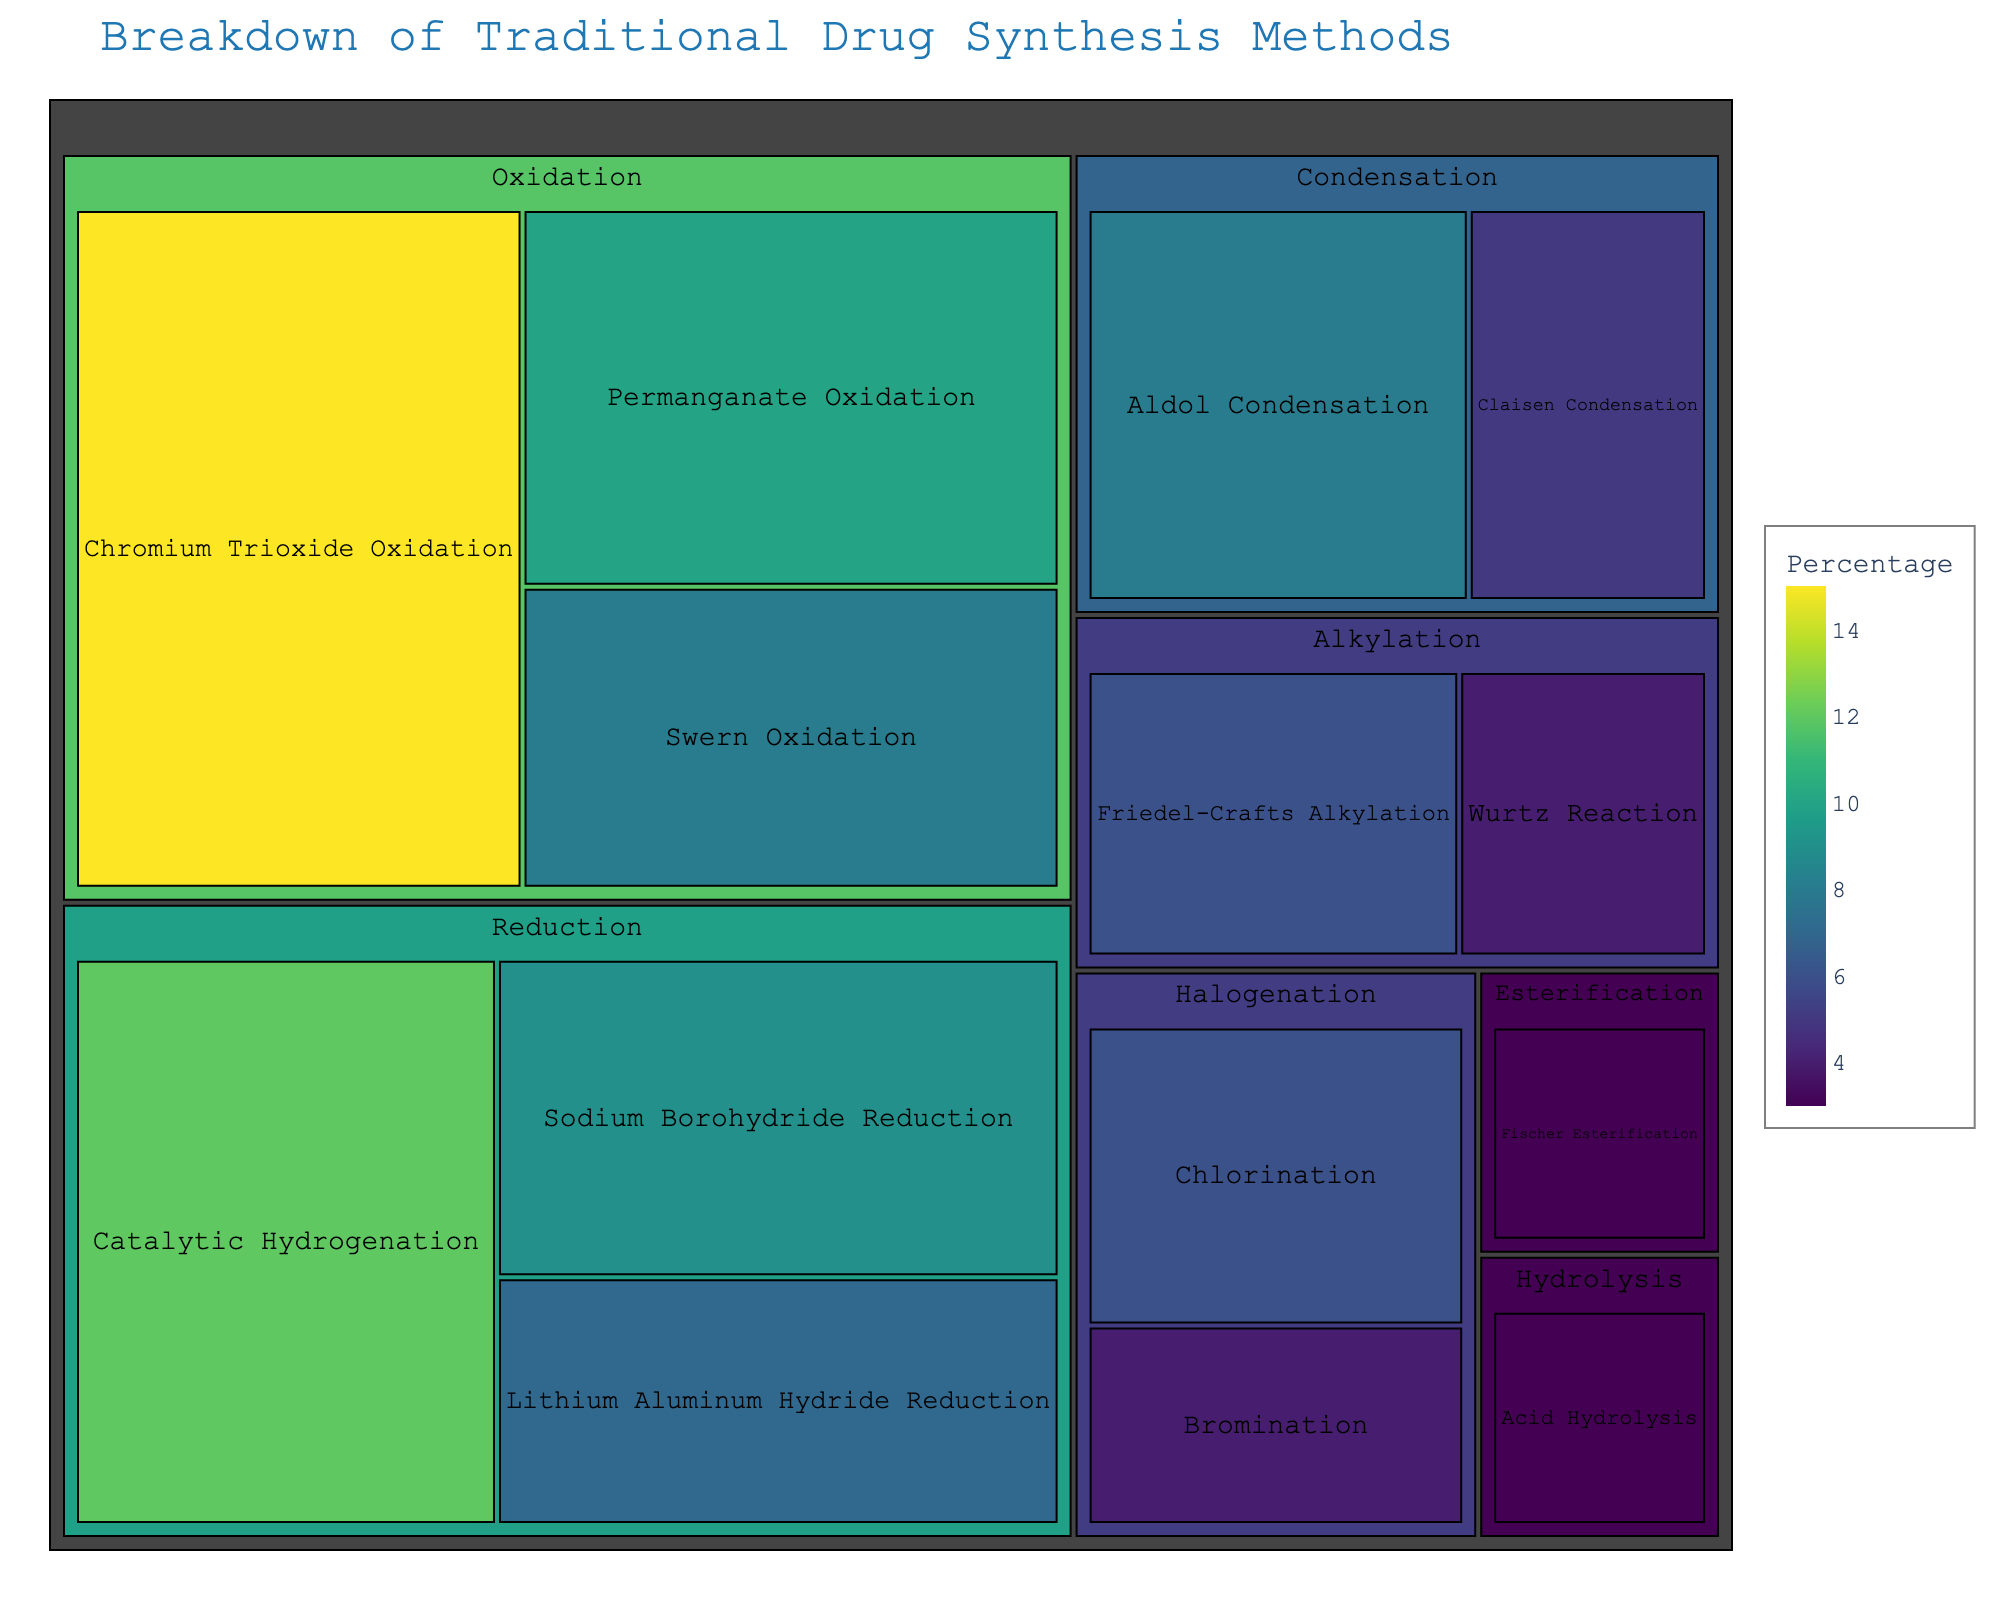What is the title of the treemap? The title is typically located at the top of the figure and provides a brief description of what the figure is about. In this case, the title is "Breakdown of Traditional Drug Synthesis Methods".
Answer: Breakdown of Traditional Drug Synthesis Methods Which method has the highest percentage among all chemical reaction types? The largest block in the treemap indicates the method with the highest percentage. From the data, it's "Chromium Trioxide Oxidation" in the "Oxidation" category with 15%.
Answer: Chromium Trioxide Oxidation What is the total percentage of all reduction methods combined? To find the total percentage for reduction methods, sum the percentages of all methods under the "Reduction" category: Catalytic Hydrogenation (12%), Sodium Borohydride Reduction (9%), Lithium Aluminum Hydride Reduction (7%). So, 12 + 9 + 7 = 28%.
Answer: 28% Which category has the most diverse types of methods, and how many methods are there in it? By counting the individual methods in each category, we see that "Oxidation" has the highest diversity with three methods: Chromium Trioxide Oxidation, Permanganate Oxidation, Swern Oxidation.
Answer: Oxidation, 3 methods Compare the percentages of the "Friedel-Crafts Alkylation" and "Wurtz Reaction". Which one is higher and by how much? First, locate both methods in the "Alkylation" category. "Friedel-Crafts Alkylation" has 6% and "Wurtz Reaction" has 4%. The difference is 6 - 4 = 2%.
Answer: Friedel-Crafts Alkylation, higher by 2% What are the two smallest methods in terms of percentage, and what categories do they belong to? The smallest blocks in the treemap represent the smallest percentages. From the data, "Fischer Esterification" and "Acid Hydrolysis" both have 3%.
Answer: Fischer Esterification (Esterification), Acid Hydrolysis (Hydrolysis) Sum the percentages of all categories except "Oxidation". What is the remaining total? First, sum the percentages of "Oxidation": 15 + 10 + 8 = 33. Subtract this from the total 100%. So, 100 - 33 = 67%.
Answer: 67% What method under the Reduction category has the lowest percentage? Look at the "Reduction" category and compare the percentages: Catalytic Hydrogenation (12%), Sodium Borohydride Reduction (9%), Lithium Aluminum Hydride Reduction (7%). The lowest is "Lithium Aluminum Hydride Reduction" with 7%.
Answer: Lithium Aluminum Hydride Reduction If we group "Friedel-Crafts Alkylation" and "Aldol Condensation" together, what percentage do they cover? "Friedel-Crafts Alkylation" is 6% and "Aldol Condensation" is 8%. Adding them together: 6 + 8 = 14%.
Answer: 14% 